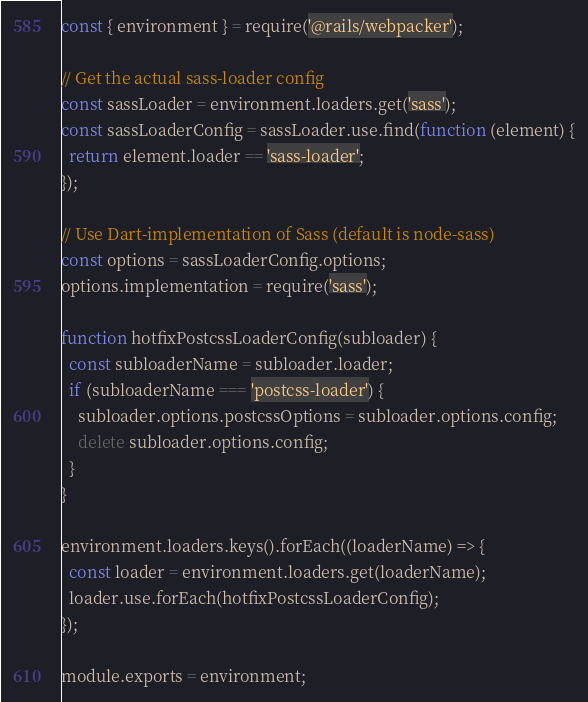<code> <loc_0><loc_0><loc_500><loc_500><_JavaScript_>const { environment } = require('@rails/webpacker');

// Get the actual sass-loader config
const sassLoader = environment.loaders.get('sass');
const sassLoaderConfig = sassLoader.use.find(function (element) {
  return element.loader == 'sass-loader';
});

// Use Dart-implementation of Sass (default is node-sass)
const options = sassLoaderConfig.options;
options.implementation = require('sass');

function hotfixPostcssLoaderConfig(subloader) {
  const subloaderName = subloader.loader;
  if (subloaderName === 'postcss-loader') {
    subloader.options.postcssOptions = subloader.options.config;
    delete subloader.options.config;
  }
}

environment.loaders.keys().forEach((loaderName) => {
  const loader = environment.loaders.get(loaderName);
  loader.use.forEach(hotfixPostcssLoaderConfig);
});

module.exports = environment;
</code> 